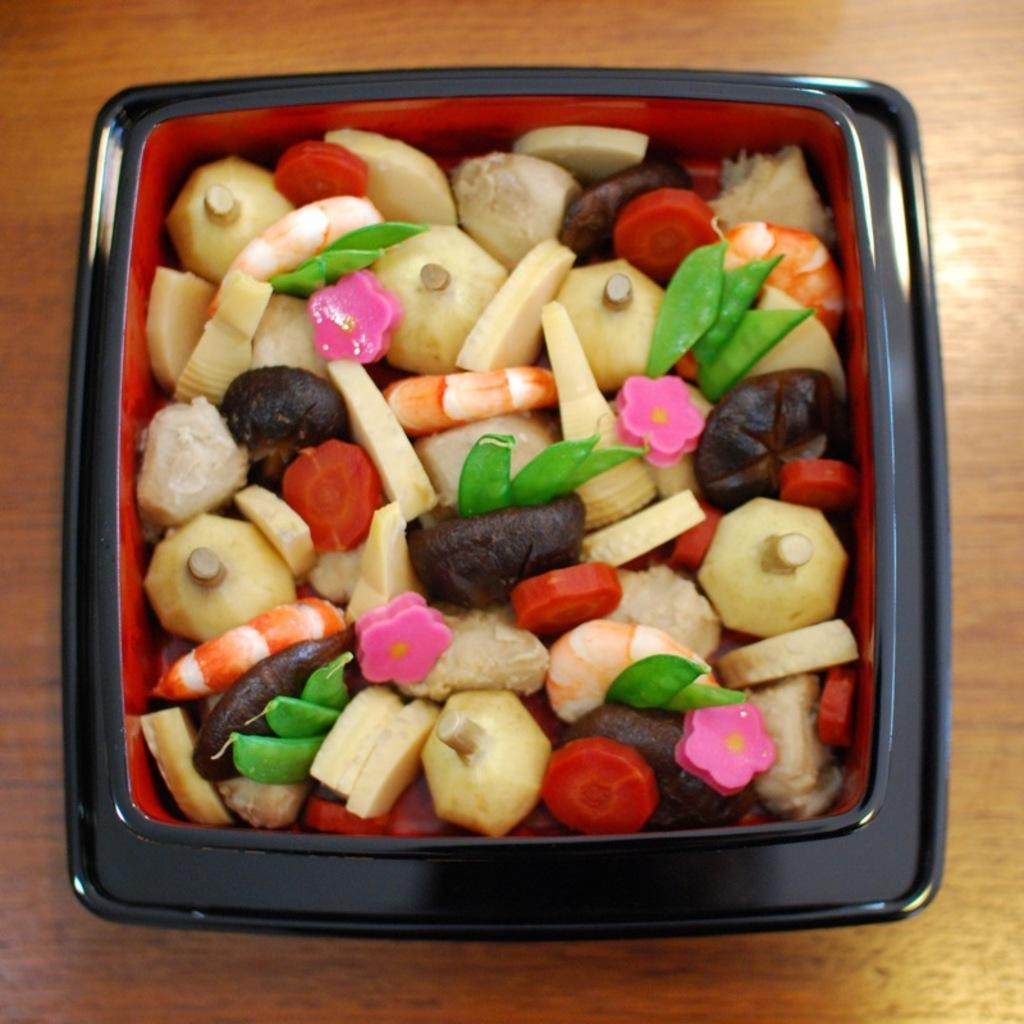What is on the table in the image? There is a box on the table in the image. What is inside the box? The box contains carrots, cabbage, potatoes, and other vegetable pieces. Can you describe the contents of the box in more detail? The box contains carrots, cabbage, potatoes, and other vegetable pieces, which are all vegetables. Who is the aunt holding a rifle in the image? There is no aunt or rifle present in the image; it only features a box containing vegetables. 